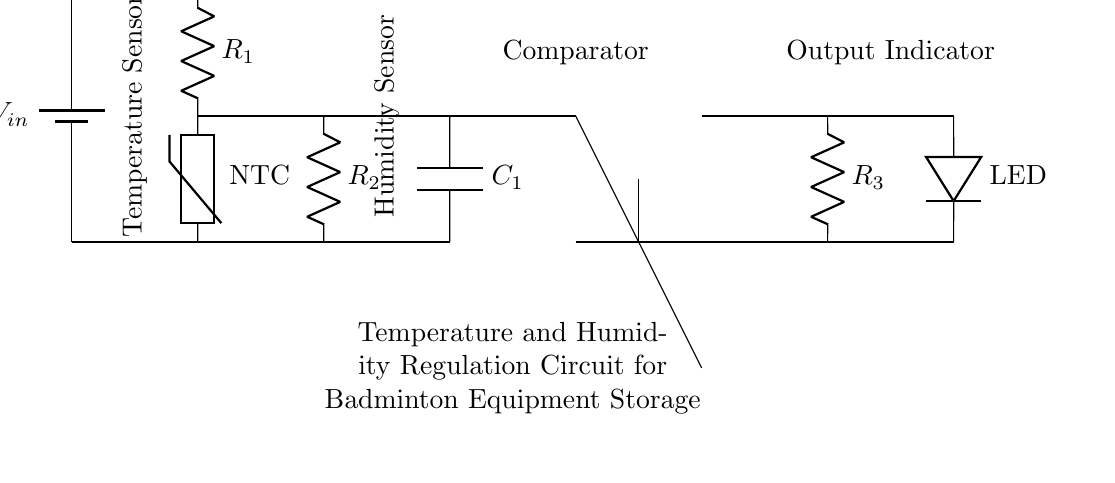What type of sensor is used for temperature measurement? The circuit diagram shows a thermistor, specifically labeled as NTC (Negative Temperature Coefficient), which means its resistance decreases as temperature increases, making it useful for temperature measurement.
Answer: Thermistor What is the function of the component labeled as "Comparator"? The comparator compares the voltage levels from the temperature and humidity sensors to determine if the conditions are appropriate for regulating the environment in the storage for badminton equipment. If the conditions are not maintained, it can trigger an action, such as turning on an indicator or activating another device.
Answer: Comparison What is the purpose of the LED in this circuit? The LED serves as an output indicator to show the operational status of the regulation system. When the temperature or humidity levels exceed the predefined thresholds, the LED activates to alert users of the condition, indicating the system is functioning.
Answer: Output Indicator How many resistors are present in the circuit? The circuit diagram shows three resistors labeled as R1, R2, and R3. Each serves unique functions in conjunction with the sensors and the rest of the circuit, affecting current and voltage levels.
Answer: Three Which component is responsible for humidity measurement? The component labeled as "Humidity Sensor" is responsible for measuring the humidity level in the storage environment, providing feedback to the circuit to maintain optimal conditions for the badminton equipment stored.
Answer: Humidity Sensor What type of capacitor is used in this circuit? The circuit uses a capacitor labeled as C1. Capacitors are generally used for smoothing voltage levels and providing stability in the circuit, which is crucial for maintaining the right operating conditions for the sensors.
Answer: Capacitor What is the primary input voltage source for this circuit? The circuit diagram indicates a voltage source labeled as Vin, which represents the power supply needed to operate all components within the temperature and humidity regulation circuit.
Answer: Vin 